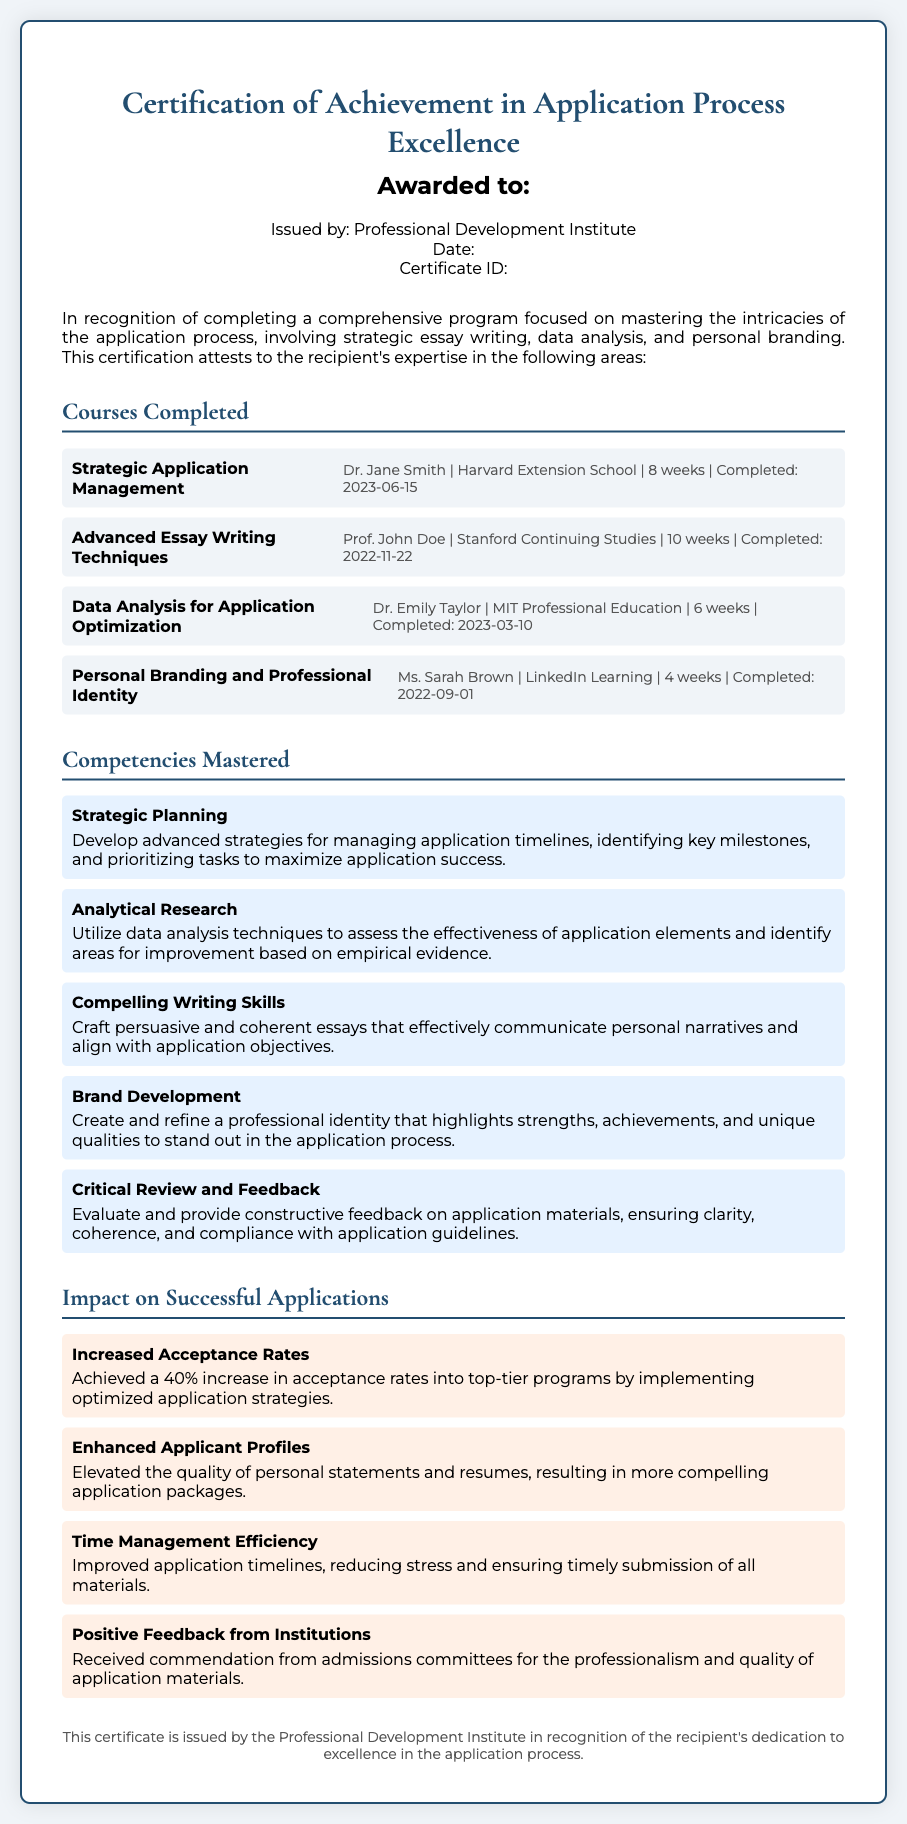what is the title of the certificate? The title of the certificate is presented prominently at the top of the document.
Answer: Certification of Achievement in Application Process Excellence who awarded the certificate? The awarding body is specified under the recipient's information.
Answer: Professional Development Institute what is the completion date of the course "Data Analysis for Application Optimization"? The completion date is mentioned in the course detail section.
Answer: 2023-03-10 who taught the course on "Personal Branding and Professional Identity"? The instructor's name for this course is provided alongside the course information.
Answer: Ms. Sarah Brown how many courses were completed in total? The total number of courses listed in the document provides a straightforward count.
Answer: 4 what competency relates to evaluating application materials? The document details specific skills mastered, including relevant competencies.
Answer: Critical Review and Feedback what percentage increase in acceptance rates was achieved? The impact section states measurable outcomes from the strategies implemented.
Answer: 40% which impact area highlights positive feedback from admissions committees? The impact areas describe the results of the certification program, specifically noting this achievement.
Answer: Positive Feedback from Institutions how long was the "Strategic Application Management" course? The document specifies the duration of each completed course.
Answer: 8 weeks 